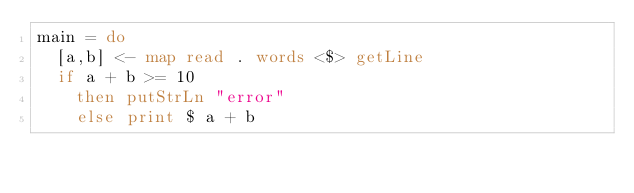Convert code to text. <code><loc_0><loc_0><loc_500><loc_500><_Haskell_>main = do
  [a,b] <- map read . words <$> getLine
  if a + b >= 10
    then putStrLn "error"
    else print $ a + b</code> 